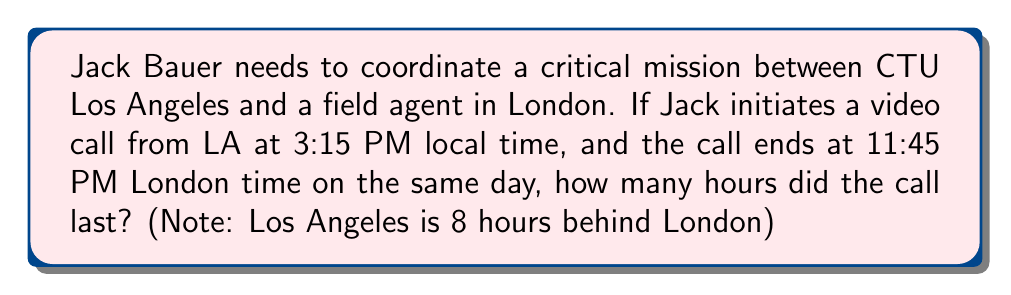What is the answer to this math problem? Let's approach this step-by-step:

1) First, we need to convert both times to the same time zone. Let's convert LA time to London time.

   LA time: 3:15 PM
   Time difference: 8 hours
   London time: 3:15 PM + 8 hours = 11:15 PM

2) Now we have:
   Call start (London time): 11:15 PM
   Call end (London time): 11:45 PM

3) To calculate the duration, we subtract:

   $$11:45 \text{ PM} - 11:15 \text{ PM} = 30 \text{ minutes}$$

4) To convert this to hours, we divide by 60:

   $$\frac{30 \text{ minutes}}{60 \text{ minutes/hour}} = 0.5 \text{ hours}$$

Therefore, the call lasted 0.5 hours or 30 minutes.
Answer: 0.5 hours 